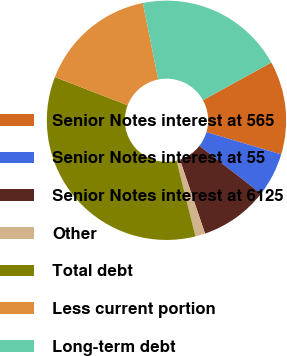Convert chart. <chart><loc_0><loc_0><loc_500><loc_500><pie_chart><fcel>Senior Notes interest at 565<fcel>Senior Notes interest at 55<fcel>Senior Notes interest at 6125<fcel>Other<fcel>Total debt<fcel>Less current portion<fcel>Long-term debt<nl><fcel>12.61%<fcel>5.92%<fcel>9.26%<fcel>1.33%<fcel>34.77%<fcel>15.95%<fcel>20.15%<nl></chart> 